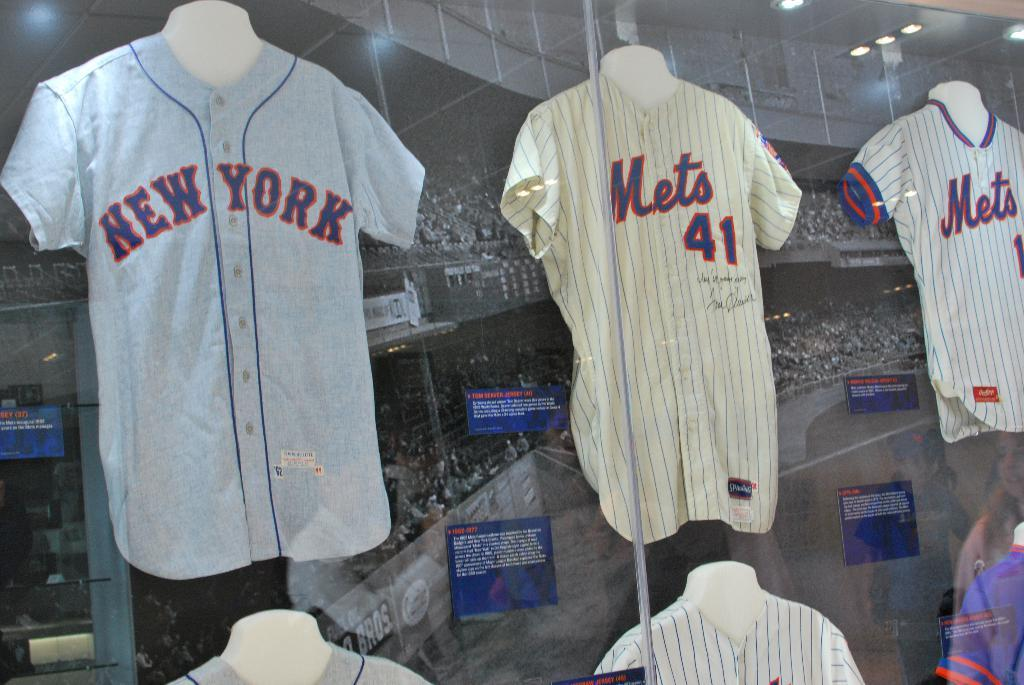<image>
Provide a brief description of the given image. Jersey's hanging near a glass display and the team is the New York Mets 